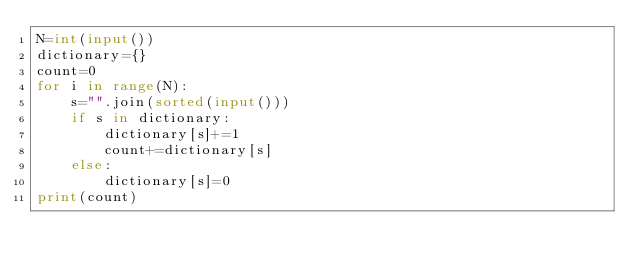Convert code to text. <code><loc_0><loc_0><loc_500><loc_500><_Python_>N=int(input())
dictionary={}
count=0
for i in range(N):
    s="".join(sorted(input()))
    if s in dictionary:
        dictionary[s]+=1
        count+=dictionary[s]
    else:
        dictionary[s]=0
print(count)</code> 